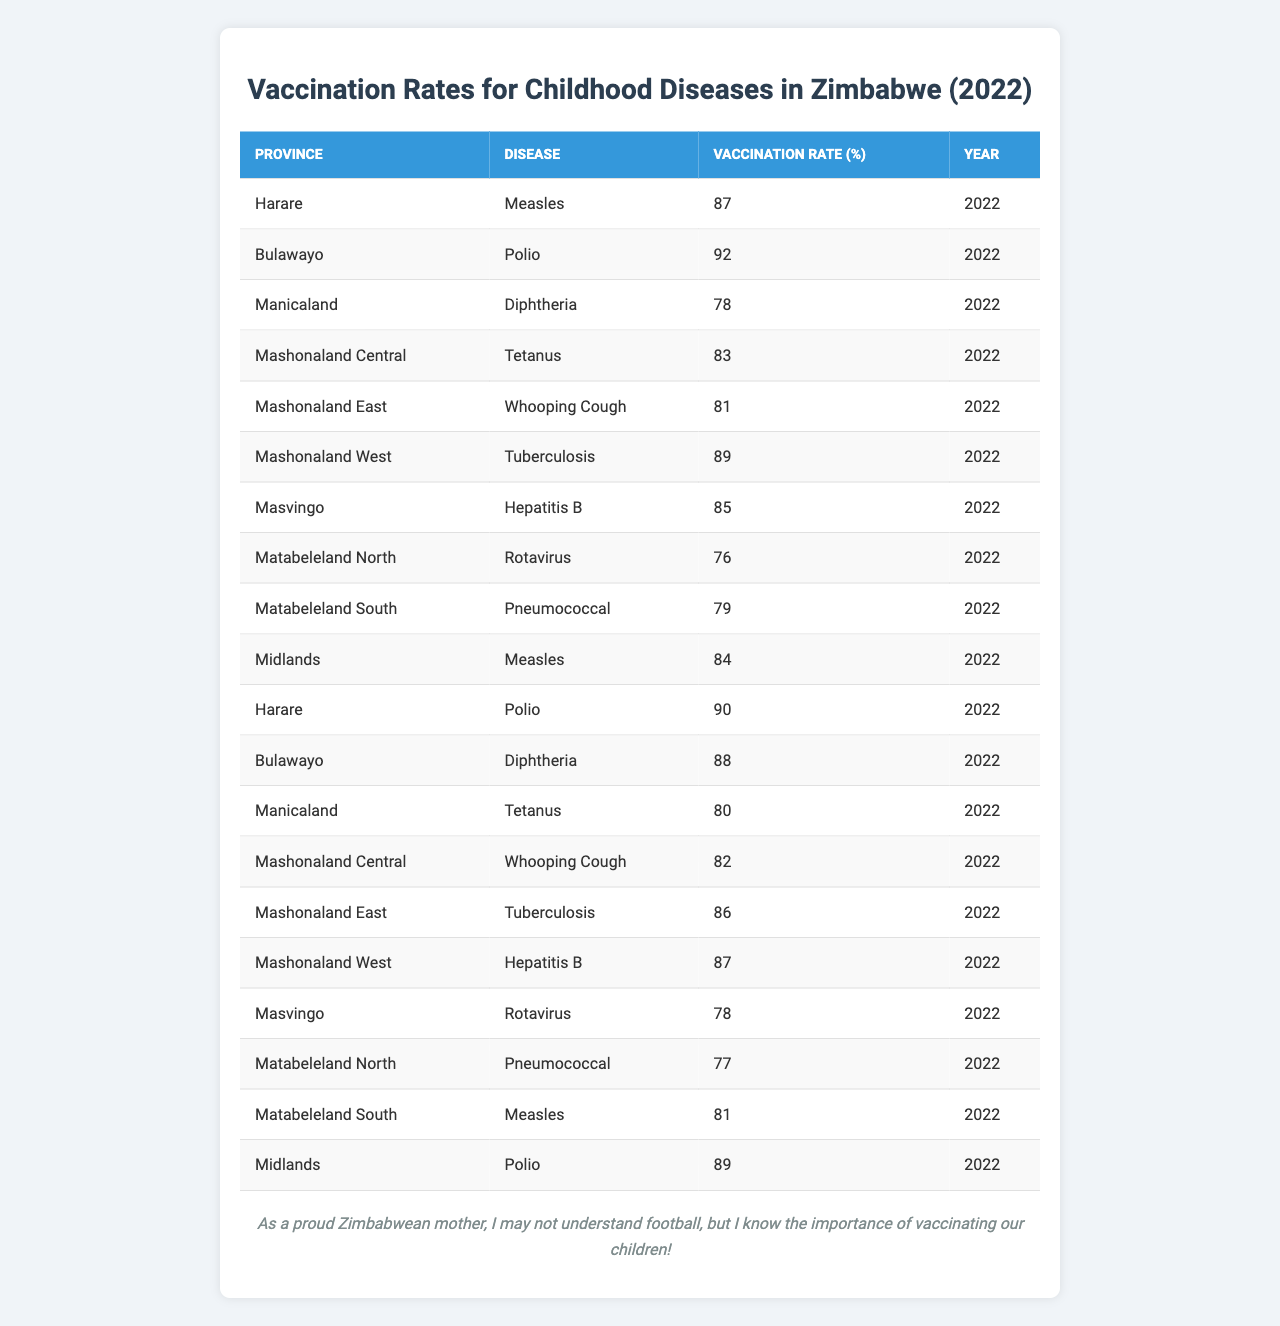What is the vaccination rate for Measles in Harare? The table shows that the vaccination rate for Measles in Harare for the year 2022 is listed as 87%.
Answer: 87% Which province has the highest vaccination rate for Polio? The table indicates that Bulawayo has the highest vaccination rate for Polio, with a rate of 92%.
Answer: Bulawayo What is the vaccination rate for Tuberculosis in Mashonaland West? According to the data, the vaccination rate for Tuberculosis in Mashonaland West is 89%.
Answer: 89% Which disease has the lowest vaccination rate in Matabeleland North? The vaccination rate for Rotavirus in Matabeleland North is the lowest at 76%.
Answer: Rotavirus What is the average vaccination rate across all provinces for Diphtheria? For Diphtheria, the vaccination rates are 78% in Manicaland and 88% in Bulawayo. The average is (78 + 88) / 2 = 83%.
Answer: 83% Is the vaccination rate for Whooping Cough in Mashonaland East higher than in Mashonaland Central? The vaccination rate for Whooping Cough in Mashonaland East is 81%, while in Mashonaland Central it's 82%. Since 81% is not greater than 82%, the statement is false.
Answer: No How many provinces have a vaccination rate for Measles above 80%? The provinces with vaccination rates for Measles above 80% are Harare (87%), Midlands (84%), and Matabeleland South (81%), totaling three provinces.
Answer: 3 What is the difference in vaccination rates for Hepatitis B between Mashonaland West and Masvingo? The vaccination rate for Hepatitis B in Mashonaland West is 87%, while in Masvingo, it is 85%. The difference is 87 - 85 = 2%.
Answer: 2% Which disease has the highest vaccination rate in Zimbabwe according to the table? The highest vaccination rate among all diseases is for Polio in Bulawayo at 92%.
Answer: Polio Are the vaccination rates for Pneumococcal disease higher in Matabeleland North compared to Matabeleland South? Matabeleland North has a vaccination rate of 77%, while Matabeleland South has 79%. Since 77% is not greater than 79%, the statement is false.
Answer: No 